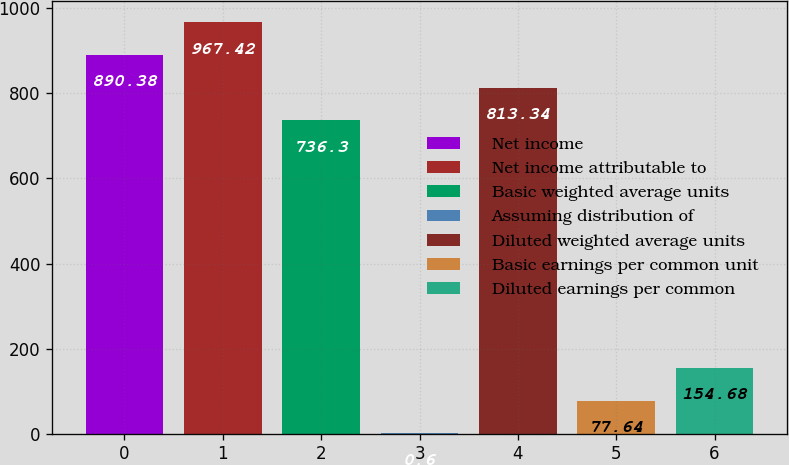Convert chart to OTSL. <chart><loc_0><loc_0><loc_500><loc_500><bar_chart><fcel>Net income<fcel>Net income attributable to<fcel>Basic weighted average units<fcel>Assuming distribution of<fcel>Diluted weighted average units<fcel>Basic earnings per common unit<fcel>Diluted earnings per common<nl><fcel>890.38<fcel>967.42<fcel>736.3<fcel>0.6<fcel>813.34<fcel>77.64<fcel>154.68<nl></chart> 